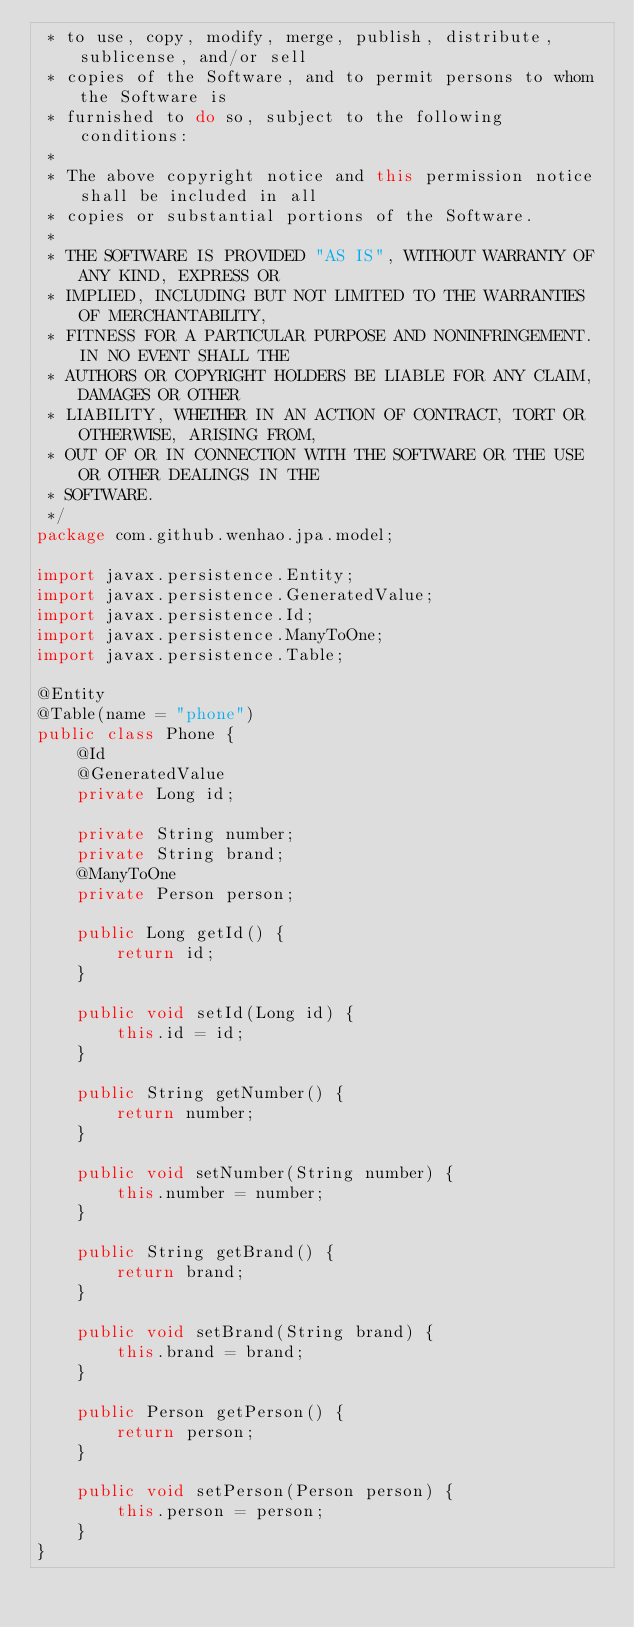Convert code to text. <code><loc_0><loc_0><loc_500><loc_500><_Java_> * to use, copy, modify, merge, publish, distribute, sublicense, and/or sell
 * copies of the Software, and to permit persons to whom the Software is
 * furnished to do so, subject to the following conditions:
 *
 * The above copyright notice and this permission notice shall be included in all
 * copies or substantial portions of the Software.
 *
 * THE SOFTWARE IS PROVIDED "AS IS", WITHOUT WARRANTY OF ANY KIND, EXPRESS OR
 * IMPLIED, INCLUDING BUT NOT LIMITED TO THE WARRANTIES OF MERCHANTABILITY,
 * FITNESS FOR A PARTICULAR PURPOSE AND NONINFRINGEMENT. IN NO EVENT SHALL THE
 * AUTHORS OR COPYRIGHT HOLDERS BE LIABLE FOR ANY CLAIM, DAMAGES OR OTHER
 * LIABILITY, WHETHER IN AN ACTION OF CONTRACT, TORT OR OTHERWISE, ARISING FROM,
 * OUT OF OR IN CONNECTION WITH THE SOFTWARE OR THE USE OR OTHER DEALINGS IN THE
 * SOFTWARE.
 */
package com.github.wenhao.jpa.model;

import javax.persistence.Entity;
import javax.persistence.GeneratedValue;
import javax.persistence.Id;
import javax.persistence.ManyToOne;
import javax.persistence.Table;

@Entity
@Table(name = "phone")
public class Phone {
    @Id
    @GeneratedValue
    private Long id;

    private String number;
    private String brand;
    @ManyToOne
    private Person person;

    public Long getId() {
        return id;
    }

    public void setId(Long id) {
        this.id = id;
    }

    public String getNumber() {
        return number;
    }

    public void setNumber(String number) {
        this.number = number;
    }

    public String getBrand() {
        return brand;
    }

    public void setBrand(String brand) {
        this.brand = brand;
    }

    public Person getPerson() {
        return person;
    }

    public void setPerson(Person person) {
        this.person = person;
    }
}
</code> 